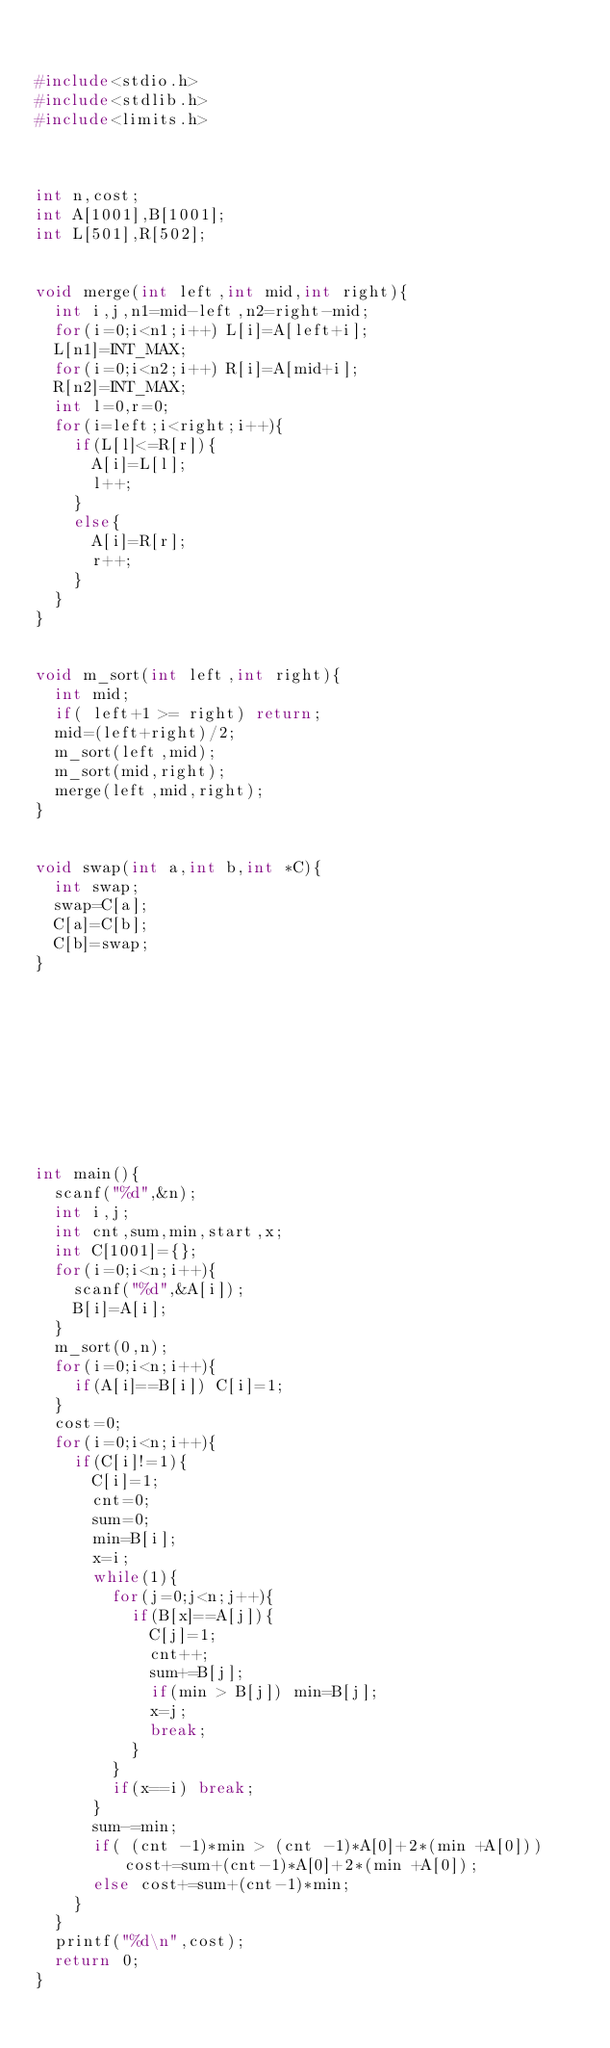Convert code to text. <code><loc_0><loc_0><loc_500><loc_500><_C_>

#include<stdio.h>
#include<stdlib.h>
#include<limits.h>
  
  
  
int n,cost;
int A[1001],B[1001];
int L[501],R[502];
  
  
void merge(int left,int mid,int right){
  int i,j,n1=mid-left,n2=right-mid;
  for(i=0;i<n1;i++) L[i]=A[left+i];
  L[n1]=INT_MAX;
  for(i=0;i<n2;i++) R[i]=A[mid+i];
  R[n2]=INT_MAX;
  int l=0,r=0;
  for(i=left;i<right;i++){
    if(L[l]<=R[r]){
      A[i]=L[l];
      l++;
    }
    else{
      A[i]=R[r];
      r++;
    }
  }
}
  
  
void m_sort(int left,int right){
  int mid;
  if( left+1 >= right) return;
  mid=(left+right)/2;
  m_sort(left,mid);
  m_sort(mid,right);
  merge(left,mid,right);
}
  
  
void swap(int a,int b,int *C){
  int swap;
  swap=C[a];
  C[a]=C[b];
  C[b]=swap;
}
  
  
  
  
  
  
    
   
    
  
int main(){
  scanf("%d",&n);
  int i,j;
  int cnt,sum,min,start,x;
  int C[1001]={};
  for(i=0;i<n;i++){
    scanf("%d",&A[i]);
    B[i]=A[i];
  }
  m_sort(0,n);
  for(i=0;i<n;i++){
    if(A[i]==B[i]) C[i]=1;
  }
  cost=0;
  for(i=0;i<n;i++){
    if(C[i]!=1){
      C[i]=1;
      cnt=0;
      sum=0;
      min=B[i];
      x=i;
      while(1){
        for(j=0;j<n;j++){
          if(B[x]==A[j]){
            C[j]=1;
            cnt++;
            sum+=B[j];
            if(min > B[j]) min=B[j];
            x=j;
            break;
          }
        }
        if(x==i) break;
      }
      sum-=min;
      if( (cnt -1)*min > (cnt -1)*A[0]+2*(min +A[0])) cost+=sum+(cnt-1)*A[0]+2*(min +A[0]);
      else cost+=sum+(cnt-1)*min;
    }
  }
  printf("%d\n",cost);
  return 0;
}
 
  </code> 